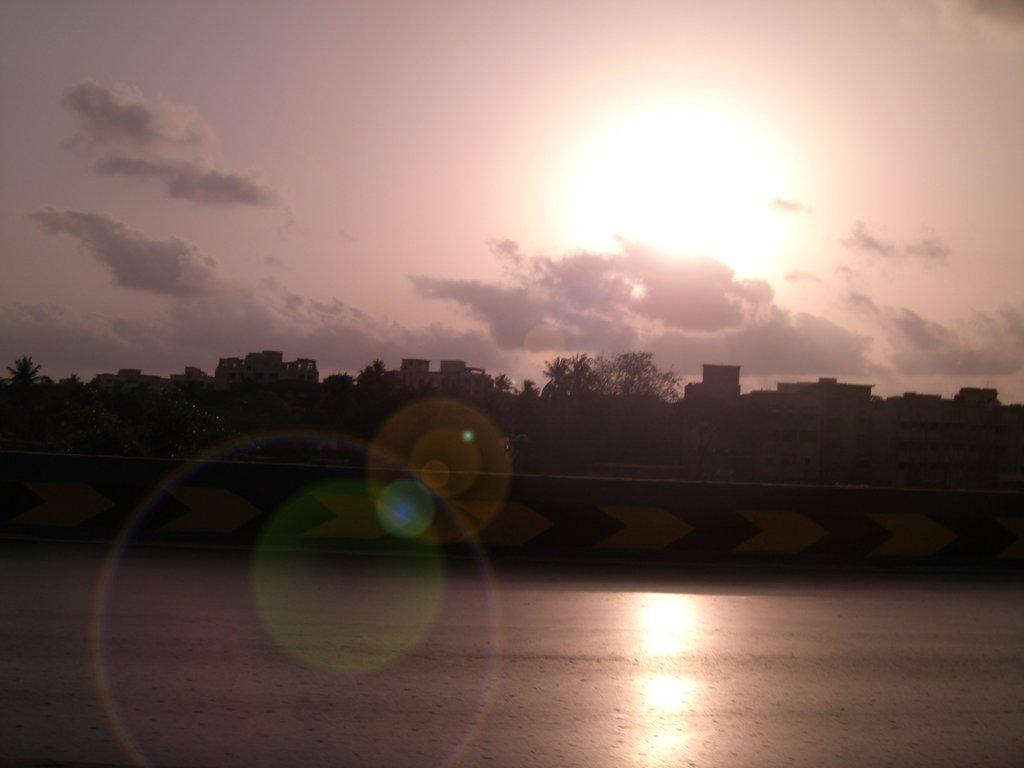What is the primary element visible in the image? There is water in the image. What other natural elements can be seen in the image? There are trees in the image. Are there any man-made structures visible? Yes, there are buildings in the image. What can be seen in the background of the image? The sky is visible in the background of the image, and clouds are present in the sky. How does the water in the image affect the stomach of the person looking at the image? The water in the image does not have any direct effect on the stomach of the person looking at the image. 